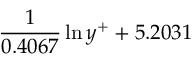Convert formula to latex. <formula><loc_0><loc_0><loc_500><loc_500>\frac { 1 } { 0 . 4 0 6 7 } \ln { y ^ { + } } + 5 . 2 0 3 1</formula> 